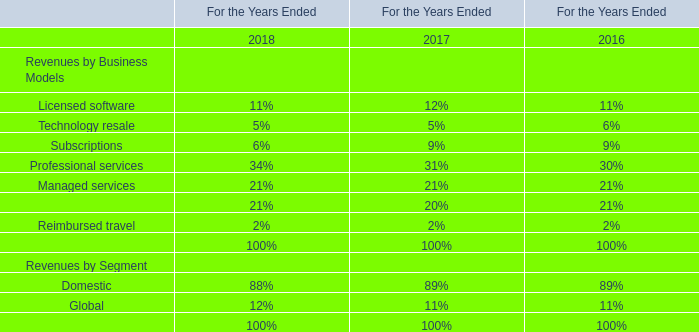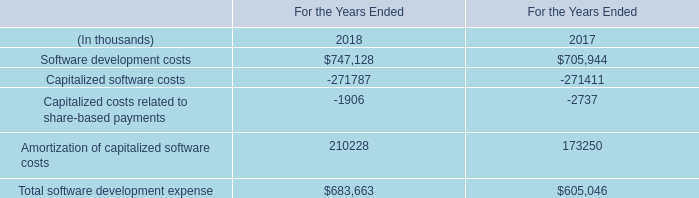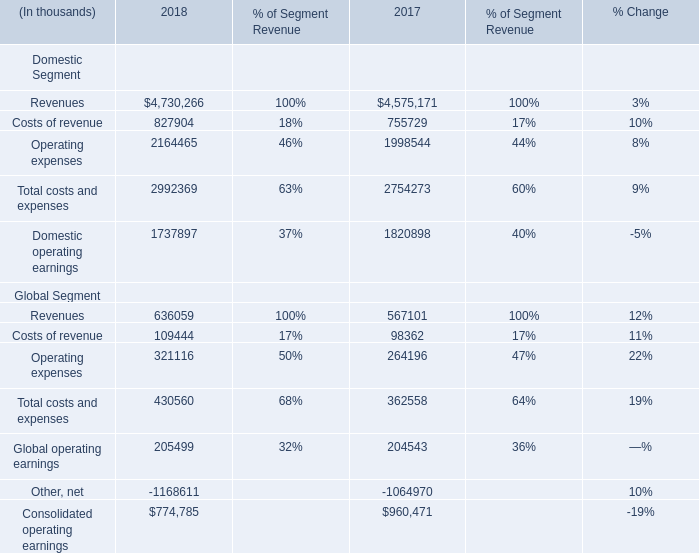If Consolidated operating earnings develops with the same growth rate in 2018, what will it reach in 2019? (in thousand) 
Computations: (774785 * (1 + ((774785 - 960471) / 960471)))
Answer: 624997.31509. 